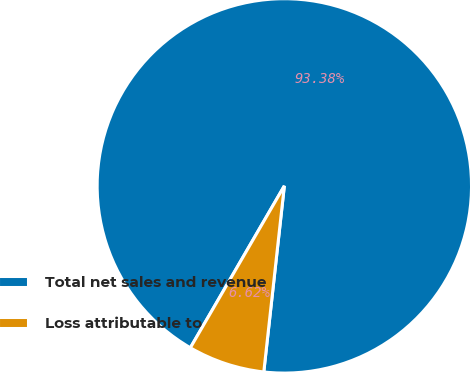Convert chart to OTSL. <chart><loc_0><loc_0><loc_500><loc_500><pie_chart><fcel>Total net sales and revenue<fcel>Loss attributable to<nl><fcel>93.38%<fcel>6.62%<nl></chart> 